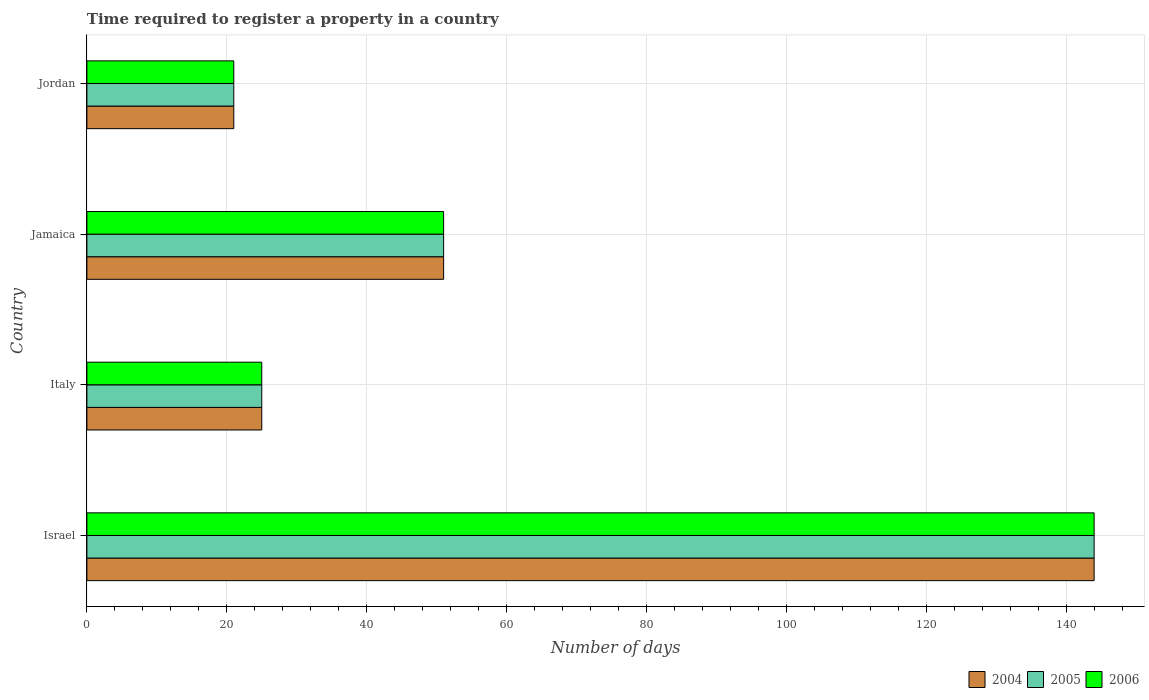How many different coloured bars are there?
Give a very brief answer. 3. How many groups of bars are there?
Offer a very short reply. 4. Are the number of bars on each tick of the Y-axis equal?
Give a very brief answer. Yes. What is the label of the 2nd group of bars from the top?
Keep it short and to the point. Jamaica. In how many cases, is the number of bars for a given country not equal to the number of legend labels?
Give a very brief answer. 0. What is the number of days required to register a property in 2005 in Jamaica?
Offer a terse response. 51. Across all countries, what is the maximum number of days required to register a property in 2005?
Your answer should be compact. 144. Across all countries, what is the minimum number of days required to register a property in 2005?
Give a very brief answer. 21. In which country was the number of days required to register a property in 2006 minimum?
Offer a terse response. Jordan. What is the total number of days required to register a property in 2006 in the graph?
Give a very brief answer. 241. What is the difference between the number of days required to register a property in 2006 in Israel and that in Italy?
Offer a terse response. 119. What is the difference between the number of days required to register a property in 2005 in Israel and the number of days required to register a property in 2004 in Jordan?
Make the answer very short. 123. What is the average number of days required to register a property in 2004 per country?
Offer a very short reply. 60.25. What is the difference between the number of days required to register a property in 2006 and number of days required to register a property in 2005 in Jordan?
Ensure brevity in your answer.  0. In how many countries, is the number of days required to register a property in 2006 greater than 132 days?
Offer a very short reply. 1. What is the ratio of the number of days required to register a property in 2005 in Israel to that in Jamaica?
Your answer should be very brief. 2.82. Is the difference between the number of days required to register a property in 2006 in Israel and Jordan greater than the difference between the number of days required to register a property in 2005 in Israel and Jordan?
Offer a terse response. No. What is the difference between the highest and the second highest number of days required to register a property in 2006?
Provide a succinct answer. 93. What is the difference between the highest and the lowest number of days required to register a property in 2006?
Keep it short and to the point. 123. In how many countries, is the number of days required to register a property in 2004 greater than the average number of days required to register a property in 2004 taken over all countries?
Ensure brevity in your answer.  1. Is the sum of the number of days required to register a property in 2006 in Italy and Jordan greater than the maximum number of days required to register a property in 2005 across all countries?
Give a very brief answer. No. How many bars are there?
Offer a very short reply. 12. How many countries are there in the graph?
Offer a terse response. 4. Are the values on the major ticks of X-axis written in scientific E-notation?
Your answer should be compact. No. Does the graph contain grids?
Offer a very short reply. Yes. Where does the legend appear in the graph?
Provide a succinct answer. Bottom right. How many legend labels are there?
Make the answer very short. 3. How are the legend labels stacked?
Your answer should be compact. Horizontal. What is the title of the graph?
Offer a terse response. Time required to register a property in a country. Does "1988" appear as one of the legend labels in the graph?
Provide a short and direct response. No. What is the label or title of the X-axis?
Make the answer very short. Number of days. What is the label or title of the Y-axis?
Provide a short and direct response. Country. What is the Number of days of 2004 in Israel?
Make the answer very short. 144. What is the Number of days of 2005 in Israel?
Provide a short and direct response. 144. What is the Number of days of 2006 in Israel?
Your response must be concise. 144. What is the Number of days of 2004 in Italy?
Ensure brevity in your answer.  25. What is the Number of days of 2005 in Italy?
Make the answer very short. 25. What is the Number of days of 2004 in Jamaica?
Your answer should be very brief. 51. What is the Number of days of 2005 in Jamaica?
Make the answer very short. 51. What is the Number of days in 2006 in Jamaica?
Your answer should be compact. 51. What is the Number of days in 2004 in Jordan?
Provide a short and direct response. 21. What is the Number of days in 2006 in Jordan?
Offer a terse response. 21. Across all countries, what is the maximum Number of days of 2004?
Provide a short and direct response. 144. Across all countries, what is the maximum Number of days in 2005?
Make the answer very short. 144. Across all countries, what is the maximum Number of days of 2006?
Provide a short and direct response. 144. Across all countries, what is the minimum Number of days in 2005?
Your answer should be very brief. 21. What is the total Number of days in 2004 in the graph?
Your response must be concise. 241. What is the total Number of days in 2005 in the graph?
Your answer should be compact. 241. What is the total Number of days in 2006 in the graph?
Provide a succinct answer. 241. What is the difference between the Number of days of 2004 in Israel and that in Italy?
Keep it short and to the point. 119. What is the difference between the Number of days of 2005 in Israel and that in Italy?
Your response must be concise. 119. What is the difference between the Number of days of 2006 in Israel and that in Italy?
Ensure brevity in your answer.  119. What is the difference between the Number of days in 2004 in Israel and that in Jamaica?
Offer a very short reply. 93. What is the difference between the Number of days in 2005 in Israel and that in Jamaica?
Your answer should be compact. 93. What is the difference between the Number of days of 2006 in Israel and that in Jamaica?
Make the answer very short. 93. What is the difference between the Number of days of 2004 in Israel and that in Jordan?
Your answer should be compact. 123. What is the difference between the Number of days of 2005 in Israel and that in Jordan?
Provide a succinct answer. 123. What is the difference between the Number of days of 2006 in Israel and that in Jordan?
Make the answer very short. 123. What is the difference between the Number of days of 2004 in Italy and that in Jamaica?
Your answer should be compact. -26. What is the difference between the Number of days in 2006 in Italy and that in Jamaica?
Provide a short and direct response. -26. What is the difference between the Number of days in 2004 in Italy and that in Jordan?
Your answer should be very brief. 4. What is the difference between the Number of days in 2004 in Jamaica and that in Jordan?
Make the answer very short. 30. What is the difference between the Number of days of 2006 in Jamaica and that in Jordan?
Make the answer very short. 30. What is the difference between the Number of days in 2004 in Israel and the Number of days in 2005 in Italy?
Provide a short and direct response. 119. What is the difference between the Number of days in 2004 in Israel and the Number of days in 2006 in Italy?
Offer a terse response. 119. What is the difference between the Number of days in 2005 in Israel and the Number of days in 2006 in Italy?
Offer a terse response. 119. What is the difference between the Number of days in 2004 in Israel and the Number of days in 2005 in Jamaica?
Offer a terse response. 93. What is the difference between the Number of days in 2004 in Israel and the Number of days in 2006 in Jamaica?
Your answer should be compact. 93. What is the difference between the Number of days in 2005 in Israel and the Number of days in 2006 in Jamaica?
Give a very brief answer. 93. What is the difference between the Number of days in 2004 in Israel and the Number of days in 2005 in Jordan?
Your response must be concise. 123. What is the difference between the Number of days of 2004 in Israel and the Number of days of 2006 in Jordan?
Your answer should be very brief. 123. What is the difference between the Number of days in 2005 in Israel and the Number of days in 2006 in Jordan?
Give a very brief answer. 123. What is the difference between the Number of days of 2004 in Italy and the Number of days of 2006 in Jamaica?
Provide a succinct answer. -26. What is the difference between the Number of days in 2004 in Italy and the Number of days in 2005 in Jordan?
Your response must be concise. 4. What is the difference between the Number of days of 2004 in Jamaica and the Number of days of 2005 in Jordan?
Make the answer very short. 30. What is the difference between the Number of days in 2005 in Jamaica and the Number of days in 2006 in Jordan?
Provide a short and direct response. 30. What is the average Number of days in 2004 per country?
Offer a very short reply. 60.25. What is the average Number of days in 2005 per country?
Offer a terse response. 60.25. What is the average Number of days in 2006 per country?
Keep it short and to the point. 60.25. What is the difference between the Number of days in 2004 and Number of days in 2005 in Israel?
Make the answer very short. 0. What is the difference between the Number of days of 2005 and Number of days of 2006 in Israel?
Your answer should be very brief. 0. What is the difference between the Number of days of 2004 and Number of days of 2005 in Italy?
Your response must be concise. 0. What is the difference between the Number of days of 2004 and Number of days of 2006 in Italy?
Offer a terse response. 0. What is the difference between the Number of days in 2004 and Number of days in 2005 in Jamaica?
Make the answer very short. 0. What is the difference between the Number of days of 2004 and Number of days of 2005 in Jordan?
Your response must be concise. 0. What is the difference between the Number of days of 2005 and Number of days of 2006 in Jordan?
Keep it short and to the point. 0. What is the ratio of the Number of days of 2004 in Israel to that in Italy?
Give a very brief answer. 5.76. What is the ratio of the Number of days in 2005 in Israel to that in Italy?
Provide a short and direct response. 5.76. What is the ratio of the Number of days in 2006 in Israel to that in Italy?
Provide a succinct answer. 5.76. What is the ratio of the Number of days of 2004 in Israel to that in Jamaica?
Offer a terse response. 2.82. What is the ratio of the Number of days of 2005 in Israel to that in Jamaica?
Provide a succinct answer. 2.82. What is the ratio of the Number of days of 2006 in Israel to that in Jamaica?
Offer a very short reply. 2.82. What is the ratio of the Number of days in 2004 in Israel to that in Jordan?
Make the answer very short. 6.86. What is the ratio of the Number of days in 2005 in Israel to that in Jordan?
Provide a short and direct response. 6.86. What is the ratio of the Number of days in 2006 in Israel to that in Jordan?
Offer a very short reply. 6.86. What is the ratio of the Number of days of 2004 in Italy to that in Jamaica?
Provide a short and direct response. 0.49. What is the ratio of the Number of days of 2005 in Italy to that in Jamaica?
Make the answer very short. 0.49. What is the ratio of the Number of days in 2006 in Italy to that in Jamaica?
Offer a very short reply. 0.49. What is the ratio of the Number of days in 2004 in Italy to that in Jordan?
Make the answer very short. 1.19. What is the ratio of the Number of days in 2005 in Italy to that in Jordan?
Keep it short and to the point. 1.19. What is the ratio of the Number of days of 2006 in Italy to that in Jordan?
Your response must be concise. 1.19. What is the ratio of the Number of days in 2004 in Jamaica to that in Jordan?
Ensure brevity in your answer.  2.43. What is the ratio of the Number of days in 2005 in Jamaica to that in Jordan?
Keep it short and to the point. 2.43. What is the ratio of the Number of days of 2006 in Jamaica to that in Jordan?
Give a very brief answer. 2.43. What is the difference between the highest and the second highest Number of days in 2004?
Offer a terse response. 93. What is the difference between the highest and the second highest Number of days of 2005?
Provide a succinct answer. 93. What is the difference between the highest and the second highest Number of days in 2006?
Make the answer very short. 93. What is the difference between the highest and the lowest Number of days of 2004?
Give a very brief answer. 123. What is the difference between the highest and the lowest Number of days of 2005?
Keep it short and to the point. 123. What is the difference between the highest and the lowest Number of days in 2006?
Provide a short and direct response. 123. 